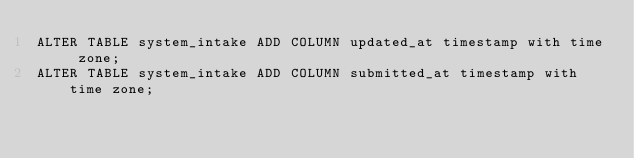<code> <loc_0><loc_0><loc_500><loc_500><_SQL_>ALTER TABLE system_intake ADD COLUMN updated_at timestamp with time zone;
ALTER TABLE system_intake ADD COLUMN submitted_at timestamp with time zone;</code> 